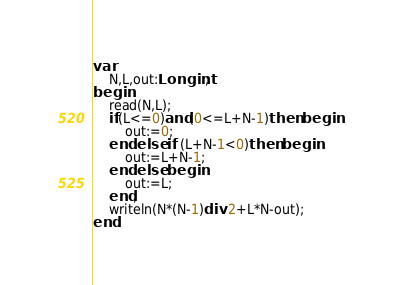<code> <loc_0><loc_0><loc_500><loc_500><_Pascal_>var
	N,L,out:Longint;
begin
	read(N,L);
	if(L<=0)and(0<=L+N-1)then begin
		out:=0;
	end else if (L+N-1<0)then begin
		out:=L+N-1;
	end else begin
		out:=L;
	end;
	writeln(N*(N-1)div 2+L*N-out);
end.
</code> 